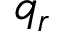Convert formula to latex. <formula><loc_0><loc_0><loc_500><loc_500>q _ { r }</formula> 